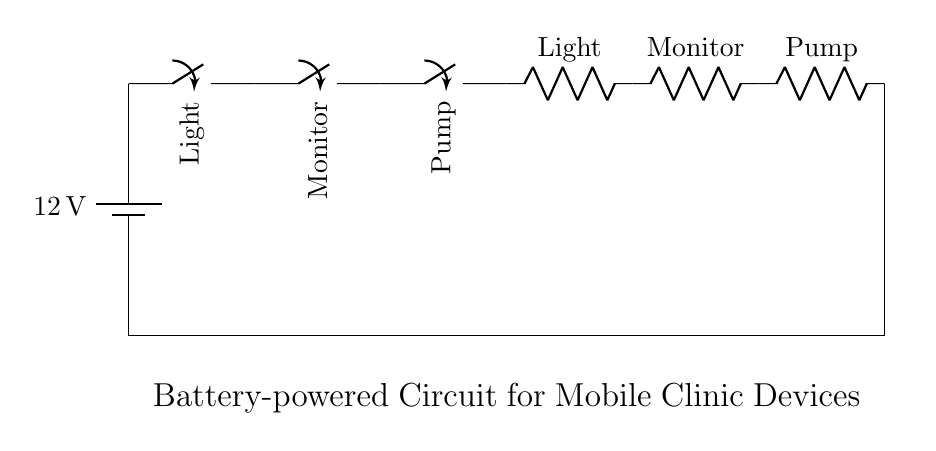What is the voltage of the battery? The voltage indicated in the circuit diagram is 12 volts, which is specified next to the battery symbol.
Answer: 12 volts What devices are controlled by the switches? The devices controlled by the switches are the light, monitor, and pump. Each device is connected in series with its respective switch.
Answer: Light, Monitor, Pump How many switches are there in the circuit? The diagram shows three switches connected in series, each corresponding to a different medical device.
Answer: Three What type of connection is used between the components? The components are connected in series, meaning that the current must flow through each switch and device sequentially for them to function.
Answer: Series What happens if one switch is open? If any of the switches is open, the circuit will be incomplete, and no current will flow, resulting in all devices being powered off.
Answer: All devices off What does the resistance symbolize in the circuit? The resistors in this circuit symbolize the light, monitor, and pump, representing their load and how they consume power when activated.
Answer: Light, Monitor, Pump Which switch controls the light? The first switch (SW1) in the series is specifically designated to control the light, as indicated in the labeling of the circuit.
Answer: SW1 